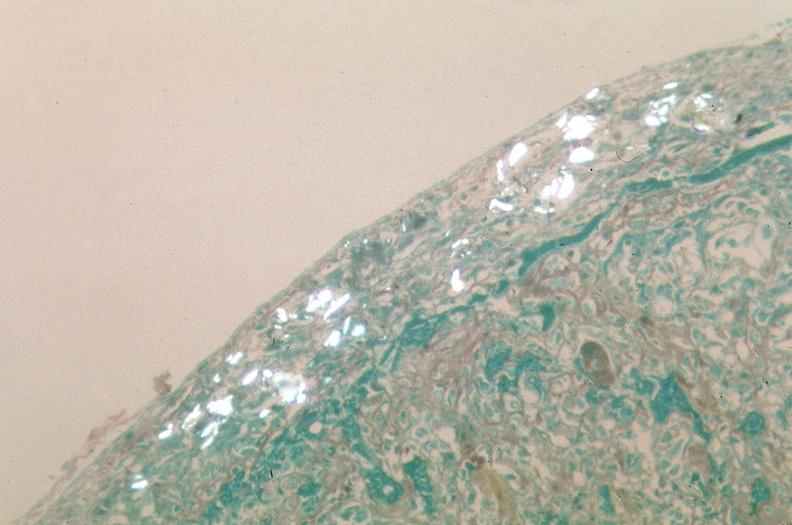what stain?
Answer the question using a single word or phrase. Trichrome 